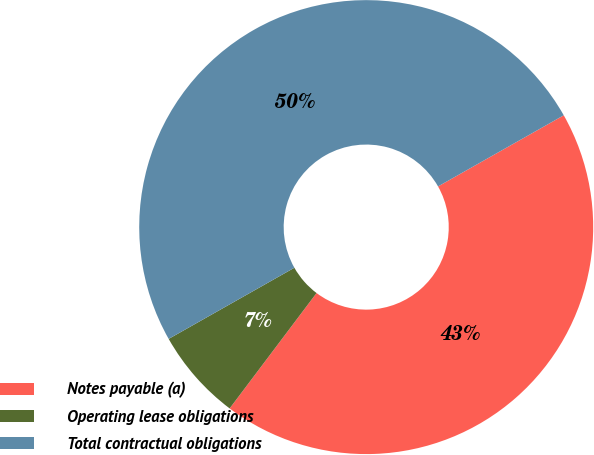Convert chart to OTSL. <chart><loc_0><loc_0><loc_500><loc_500><pie_chart><fcel>Notes payable (a)<fcel>Operating lease obligations<fcel>Total contractual obligations<nl><fcel>43.47%<fcel>6.53%<fcel>50.0%<nl></chart> 